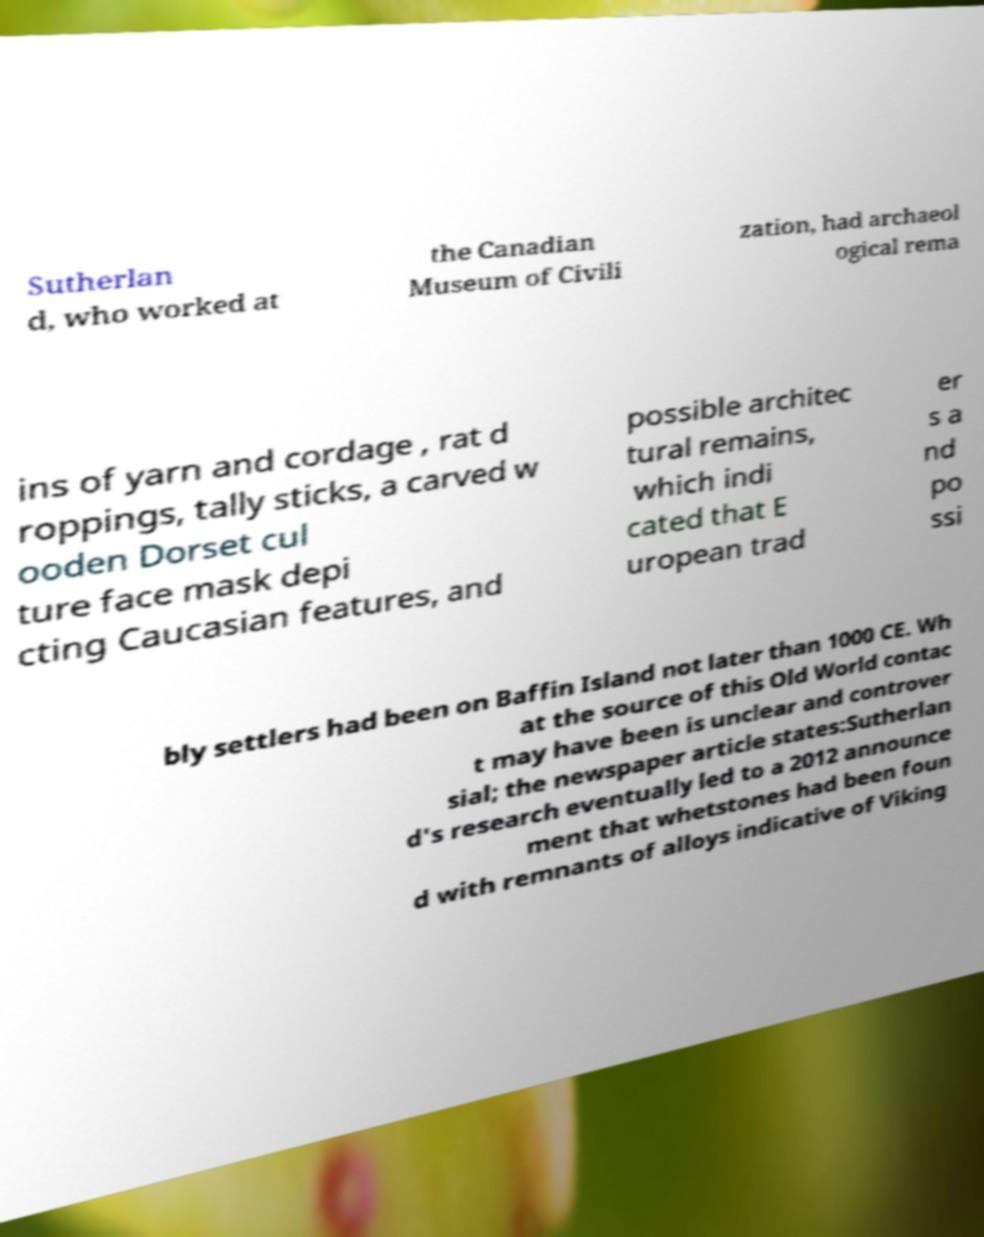What messages or text are displayed in this image? I need them in a readable, typed format. Sutherlan d, who worked at the Canadian Museum of Civili zation, had archaeol ogical rema ins of yarn and cordage , rat d roppings, tally sticks, a carved w ooden Dorset cul ture face mask depi cting Caucasian features, and possible architec tural remains, which indi cated that E uropean trad er s a nd po ssi bly settlers had been on Baffin Island not later than 1000 CE. Wh at the source of this Old World contac t may have been is unclear and controver sial; the newspaper article states:Sutherlan d's research eventually led to a 2012 announce ment that whetstones had been foun d with remnants of alloys indicative of Viking 